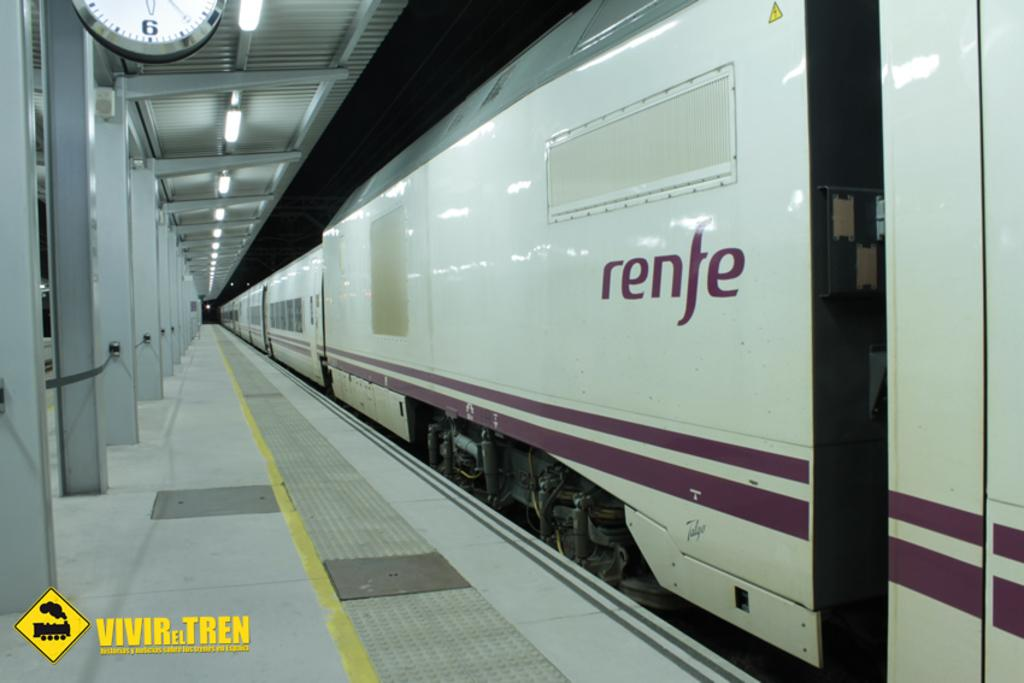<image>
Share a concise interpretation of the image provided. the word renfe is on the side of a train 